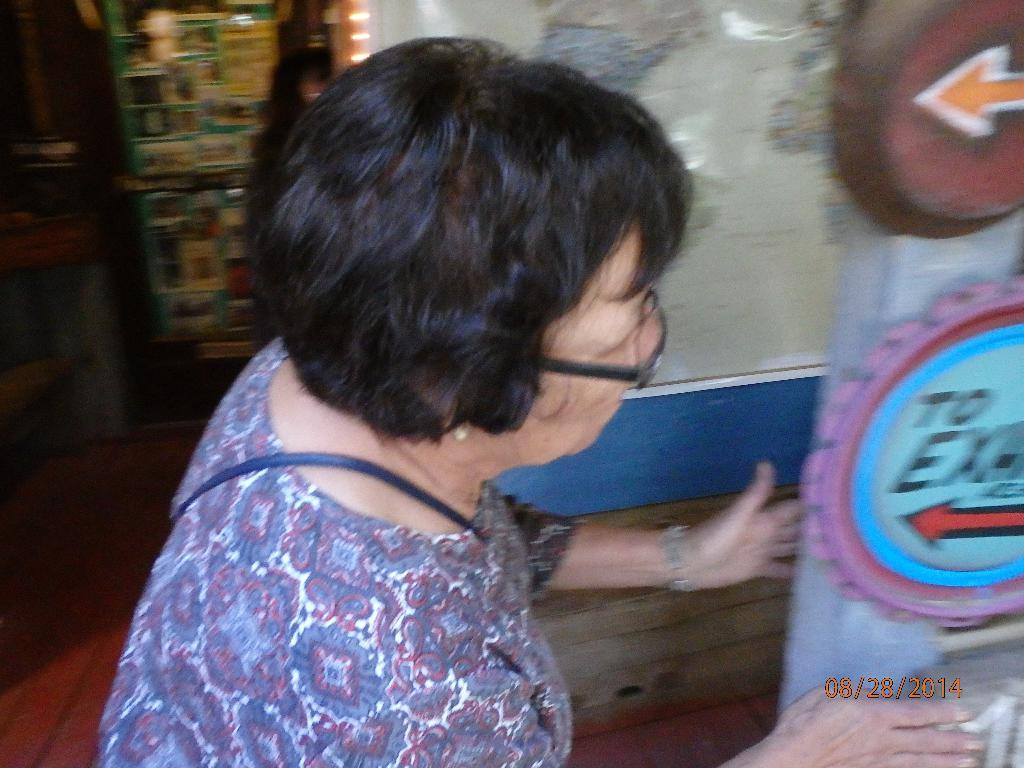Who is the main subject in the image? There is a woman in the image. What is the woman wearing on her face? The woman is wearing spectacles. What is the object in front of the woman? The facts do not specify the object in front of the woman. What can be seen in the background of the image? There are lights, a floor, and other objects visible in the background. What type of stitch is the woman using to create her art in the image? There is no indication in the image that the woman is creating art or using a stitch. --- Facts: 1. There is a car in the image. 2. The car is red. 3. The car has four wheels. 4. There is a road in the image. 5. The road is paved. 6. There are trees visible in the background. Absurd Topics: bird Conversation: What is the main subject in the image? There is a car in the image. What color is the car? The car is red. How many wheels does the car have? The car has four wheels. What can be seen in the background? There is a road visible in the background. What is the condition of the road? The road is paved. What type of vegetation is visible in the background? There are trees visible in the background. Reasoning: Let's think step by step in order to produce the conversation. We start by identifying the main subject of the image, which is the car. Next, we describe specific details about the car, such as its color and the number of wheels it has. Then, we observe the background of the image, noting the presence of a road and the type of vegetation visible in the background. Absurd Question/Answer: How many birds can be seen flying over the car in the image? There are no birds visible in the image. 